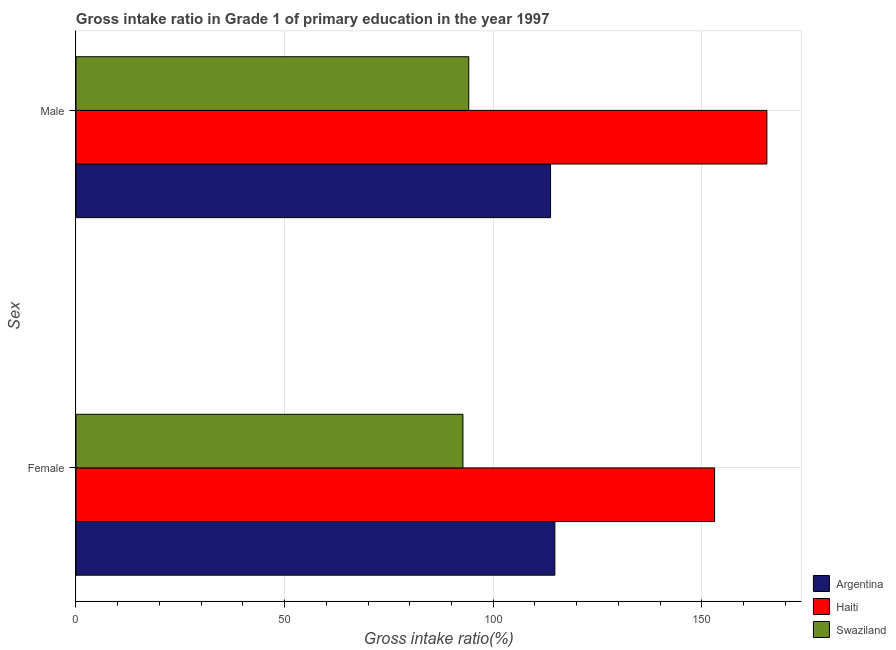Are the number of bars per tick equal to the number of legend labels?
Ensure brevity in your answer.  Yes. How many bars are there on the 2nd tick from the top?
Your response must be concise. 3. What is the gross intake ratio(female) in Haiti?
Provide a short and direct response. 153.06. Across all countries, what is the maximum gross intake ratio(male)?
Ensure brevity in your answer.  165.59. Across all countries, what is the minimum gross intake ratio(female)?
Your answer should be compact. 92.74. In which country was the gross intake ratio(female) maximum?
Ensure brevity in your answer.  Haiti. In which country was the gross intake ratio(female) minimum?
Ensure brevity in your answer.  Swaziland. What is the total gross intake ratio(female) in the graph?
Offer a very short reply. 360.58. What is the difference between the gross intake ratio(male) in Argentina and that in Swaziland?
Give a very brief answer. 19.6. What is the difference between the gross intake ratio(female) in Argentina and the gross intake ratio(male) in Swaziland?
Keep it short and to the point. 20.64. What is the average gross intake ratio(male) per country?
Give a very brief answer. 124.49. What is the difference between the gross intake ratio(male) and gross intake ratio(female) in Argentina?
Your response must be concise. -1.04. What is the ratio of the gross intake ratio(male) in Swaziland to that in Haiti?
Ensure brevity in your answer.  0.57. Is the gross intake ratio(female) in Swaziland less than that in Argentina?
Ensure brevity in your answer.  Yes. What does the 3rd bar from the bottom in Female represents?
Your response must be concise. Swaziland. How many bars are there?
Give a very brief answer. 6. How many countries are there in the graph?
Provide a short and direct response. 3. What is the difference between two consecutive major ticks on the X-axis?
Offer a terse response. 50. Are the values on the major ticks of X-axis written in scientific E-notation?
Offer a very short reply. No. Does the graph contain any zero values?
Give a very brief answer. No. How many legend labels are there?
Offer a terse response. 3. How are the legend labels stacked?
Provide a short and direct response. Vertical. What is the title of the graph?
Offer a very short reply. Gross intake ratio in Grade 1 of primary education in the year 1997. What is the label or title of the X-axis?
Keep it short and to the point. Gross intake ratio(%). What is the label or title of the Y-axis?
Ensure brevity in your answer.  Sex. What is the Gross intake ratio(%) in Argentina in Female?
Keep it short and to the point. 114.77. What is the Gross intake ratio(%) in Haiti in Female?
Your answer should be very brief. 153.06. What is the Gross intake ratio(%) in Swaziland in Female?
Your response must be concise. 92.74. What is the Gross intake ratio(%) in Argentina in Male?
Offer a very short reply. 113.74. What is the Gross intake ratio(%) of Haiti in Male?
Provide a succinct answer. 165.59. What is the Gross intake ratio(%) in Swaziland in Male?
Make the answer very short. 94.13. Across all Sex, what is the maximum Gross intake ratio(%) in Argentina?
Keep it short and to the point. 114.77. Across all Sex, what is the maximum Gross intake ratio(%) of Haiti?
Provide a short and direct response. 165.59. Across all Sex, what is the maximum Gross intake ratio(%) of Swaziland?
Keep it short and to the point. 94.13. Across all Sex, what is the minimum Gross intake ratio(%) in Argentina?
Your response must be concise. 113.74. Across all Sex, what is the minimum Gross intake ratio(%) of Haiti?
Make the answer very short. 153.06. Across all Sex, what is the minimum Gross intake ratio(%) in Swaziland?
Make the answer very short. 92.74. What is the total Gross intake ratio(%) in Argentina in the graph?
Offer a terse response. 228.51. What is the total Gross intake ratio(%) in Haiti in the graph?
Offer a very short reply. 318.65. What is the total Gross intake ratio(%) in Swaziland in the graph?
Your answer should be very brief. 186.88. What is the difference between the Gross intake ratio(%) of Argentina in Female and that in Male?
Provide a succinct answer. 1.04. What is the difference between the Gross intake ratio(%) of Haiti in Female and that in Male?
Offer a very short reply. -12.52. What is the difference between the Gross intake ratio(%) of Swaziland in Female and that in Male?
Your response must be concise. -1.39. What is the difference between the Gross intake ratio(%) of Argentina in Female and the Gross intake ratio(%) of Haiti in Male?
Give a very brief answer. -50.81. What is the difference between the Gross intake ratio(%) of Argentina in Female and the Gross intake ratio(%) of Swaziland in Male?
Your answer should be compact. 20.64. What is the difference between the Gross intake ratio(%) in Haiti in Female and the Gross intake ratio(%) in Swaziland in Male?
Provide a succinct answer. 58.93. What is the average Gross intake ratio(%) in Argentina per Sex?
Provide a short and direct response. 114.26. What is the average Gross intake ratio(%) in Haiti per Sex?
Keep it short and to the point. 159.33. What is the average Gross intake ratio(%) in Swaziland per Sex?
Your answer should be compact. 93.44. What is the difference between the Gross intake ratio(%) in Argentina and Gross intake ratio(%) in Haiti in Female?
Your answer should be compact. -38.29. What is the difference between the Gross intake ratio(%) in Argentina and Gross intake ratio(%) in Swaziland in Female?
Provide a short and direct response. 22.03. What is the difference between the Gross intake ratio(%) in Haiti and Gross intake ratio(%) in Swaziland in Female?
Provide a succinct answer. 60.32. What is the difference between the Gross intake ratio(%) of Argentina and Gross intake ratio(%) of Haiti in Male?
Give a very brief answer. -51.85. What is the difference between the Gross intake ratio(%) in Argentina and Gross intake ratio(%) in Swaziland in Male?
Your answer should be very brief. 19.6. What is the difference between the Gross intake ratio(%) in Haiti and Gross intake ratio(%) in Swaziland in Male?
Make the answer very short. 71.45. What is the ratio of the Gross intake ratio(%) of Argentina in Female to that in Male?
Ensure brevity in your answer.  1.01. What is the ratio of the Gross intake ratio(%) of Haiti in Female to that in Male?
Offer a very short reply. 0.92. What is the ratio of the Gross intake ratio(%) of Swaziland in Female to that in Male?
Offer a very short reply. 0.99. What is the difference between the highest and the second highest Gross intake ratio(%) in Argentina?
Offer a very short reply. 1.04. What is the difference between the highest and the second highest Gross intake ratio(%) of Haiti?
Give a very brief answer. 12.52. What is the difference between the highest and the second highest Gross intake ratio(%) in Swaziland?
Your response must be concise. 1.39. What is the difference between the highest and the lowest Gross intake ratio(%) in Argentina?
Offer a terse response. 1.04. What is the difference between the highest and the lowest Gross intake ratio(%) in Haiti?
Give a very brief answer. 12.52. What is the difference between the highest and the lowest Gross intake ratio(%) in Swaziland?
Provide a short and direct response. 1.39. 